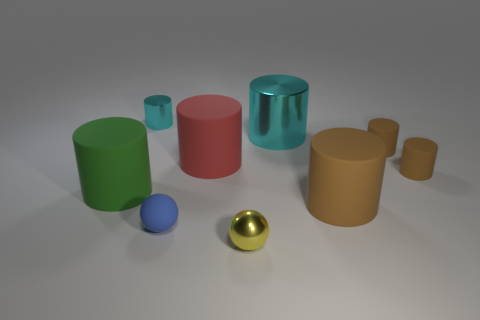Subtract all tiny matte cylinders. How many cylinders are left? 5 Subtract all yellow balls. How many brown cylinders are left? 3 Subtract 1 cylinders. How many cylinders are left? 6 Subtract all red cylinders. How many cylinders are left? 6 Subtract all gray cylinders. Subtract all green spheres. How many cylinders are left? 7 Subtract all cylinders. How many objects are left? 2 Add 6 yellow matte blocks. How many yellow matte blocks exist? 6 Subtract 0 cyan spheres. How many objects are left? 9 Subtract all big red rubber things. Subtract all metallic cylinders. How many objects are left? 6 Add 3 green cylinders. How many green cylinders are left? 4 